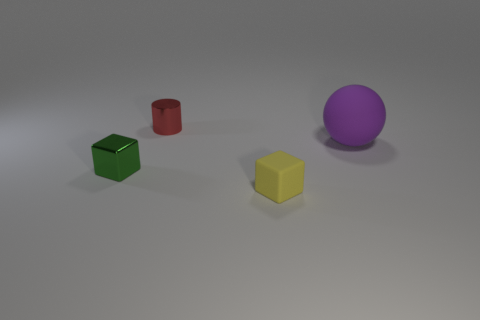Is there any other thing that has the same size as the rubber ball?
Give a very brief answer. No. Is the size of the cube that is behind the yellow matte object the same as the yellow matte cube?
Provide a succinct answer. Yes. What is the material of the small object that is behind the big purple thing?
Offer a very short reply. Metal. Are there any other things that are the same shape as the large purple object?
Provide a short and direct response. No. What number of matte objects are tiny objects or cylinders?
Ensure brevity in your answer.  1. Are there fewer yellow blocks to the left of the green thing than yellow blocks?
Ensure brevity in your answer.  Yes. The small shiny object on the left side of the metal object that is to the right of the tiny metallic thing that is in front of the large purple rubber object is what shape?
Provide a succinct answer. Cube. Is the number of red metallic things greater than the number of yellow metallic cylinders?
Offer a terse response. Yes. How many things are either small green shiny blocks or tiny shiny things behind the rubber sphere?
Ensure brevity in your answer.  2. Are there fewer tiny green metallic objects than tiny metallic objects?
Provide a succinct answer. Yes. 